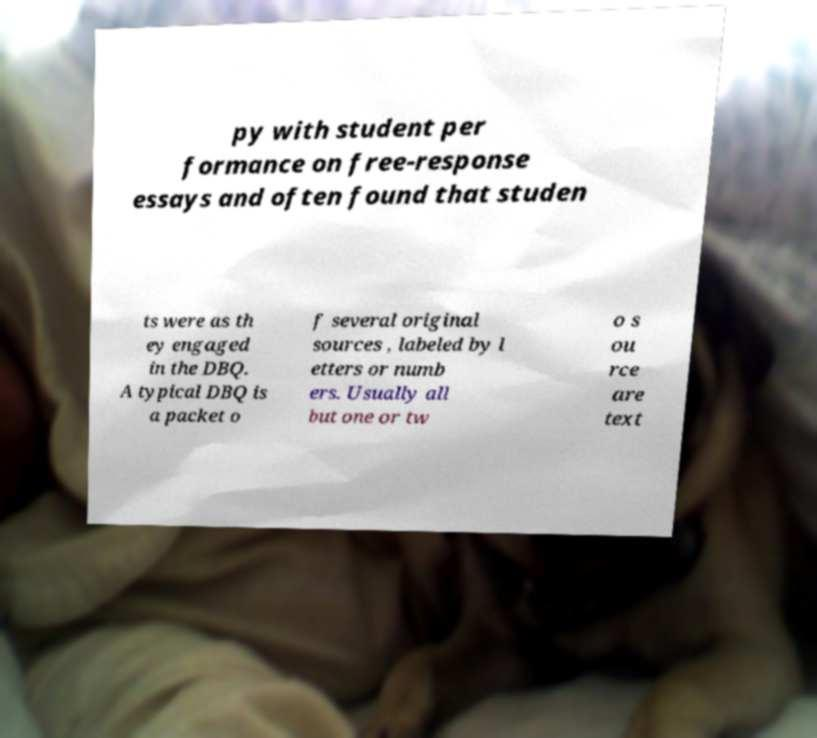Please read and relay the text visible in this image. What does it say? py with student per formance on free-response essays and often found that studen ts were as th ey engaged in the DBQ. A typical DBQ is a packet o f several original sources , labeled by l etters or numb ers. Usually all but one or tw o s ou rce are text 